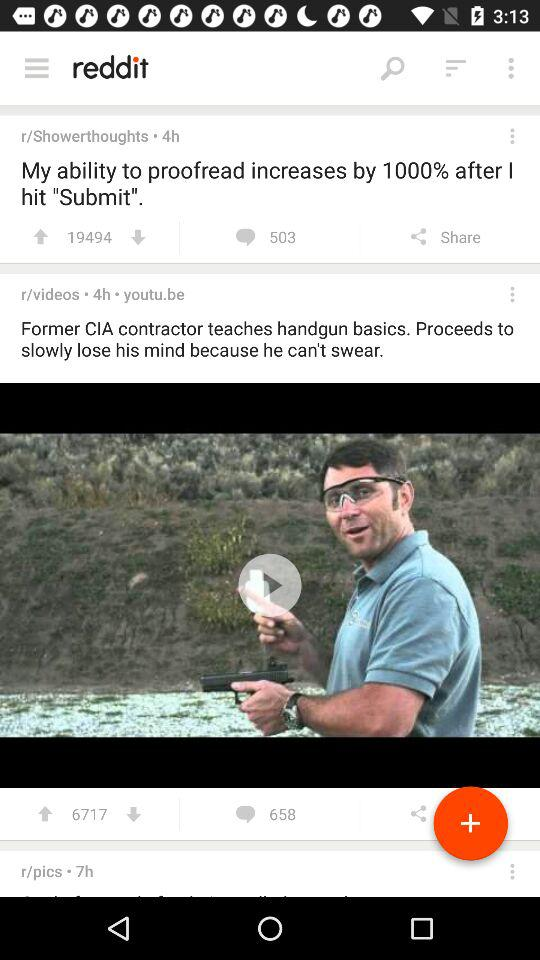How many upvotes for the video are there? There are 6717 upvotes for the video. 